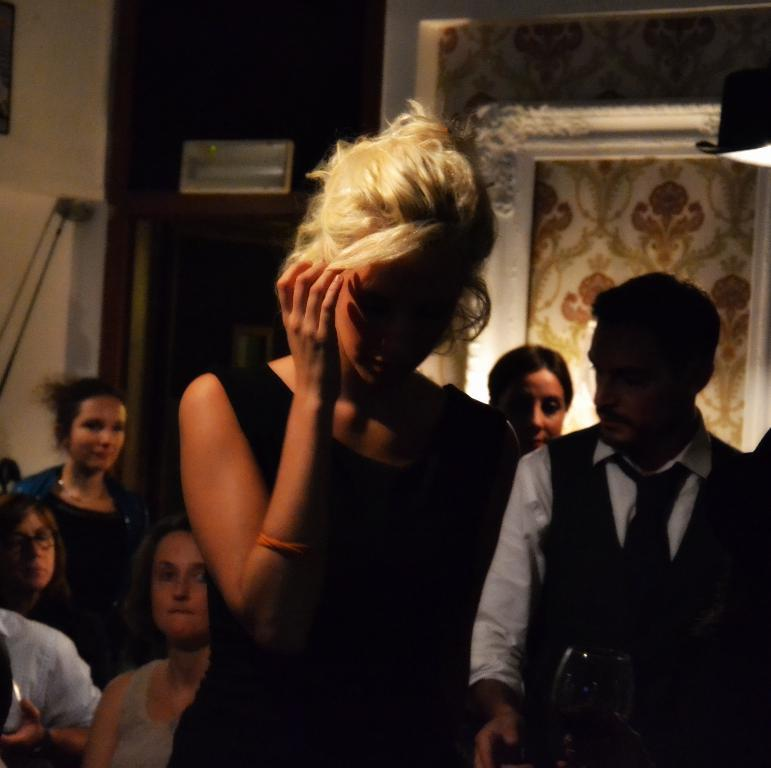How many people are present in the image? There are people in the image, but the exact number cannot be determined from the provided facts. What can be seen in the background of the image? In the background of the image, there is a board, a stand, a wall, and another object. Can you describe the board in the background? Unfortunately, the provided facts do not give any details about the board in the background. What type of cable can be seen in the throat of the person in the image? There is no person in the image with a visible throat, and there is no mention of a cable in the provided facts. 